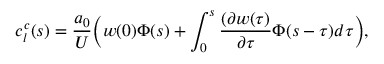<formula> <loc_0><loc_0><loc_500><loc_500>c _ { l } ^ { c } ( s ) = \frac { a _ { 0 } } { U } \left ( w ( 0 ) \Phi ( s ) + \int _ { 0 } ^ { s } \frac { ( \partial w ( \tau ) } { \partial \tau } \Phi ( s - \tau ) d \tau \right ) ,</formula> 